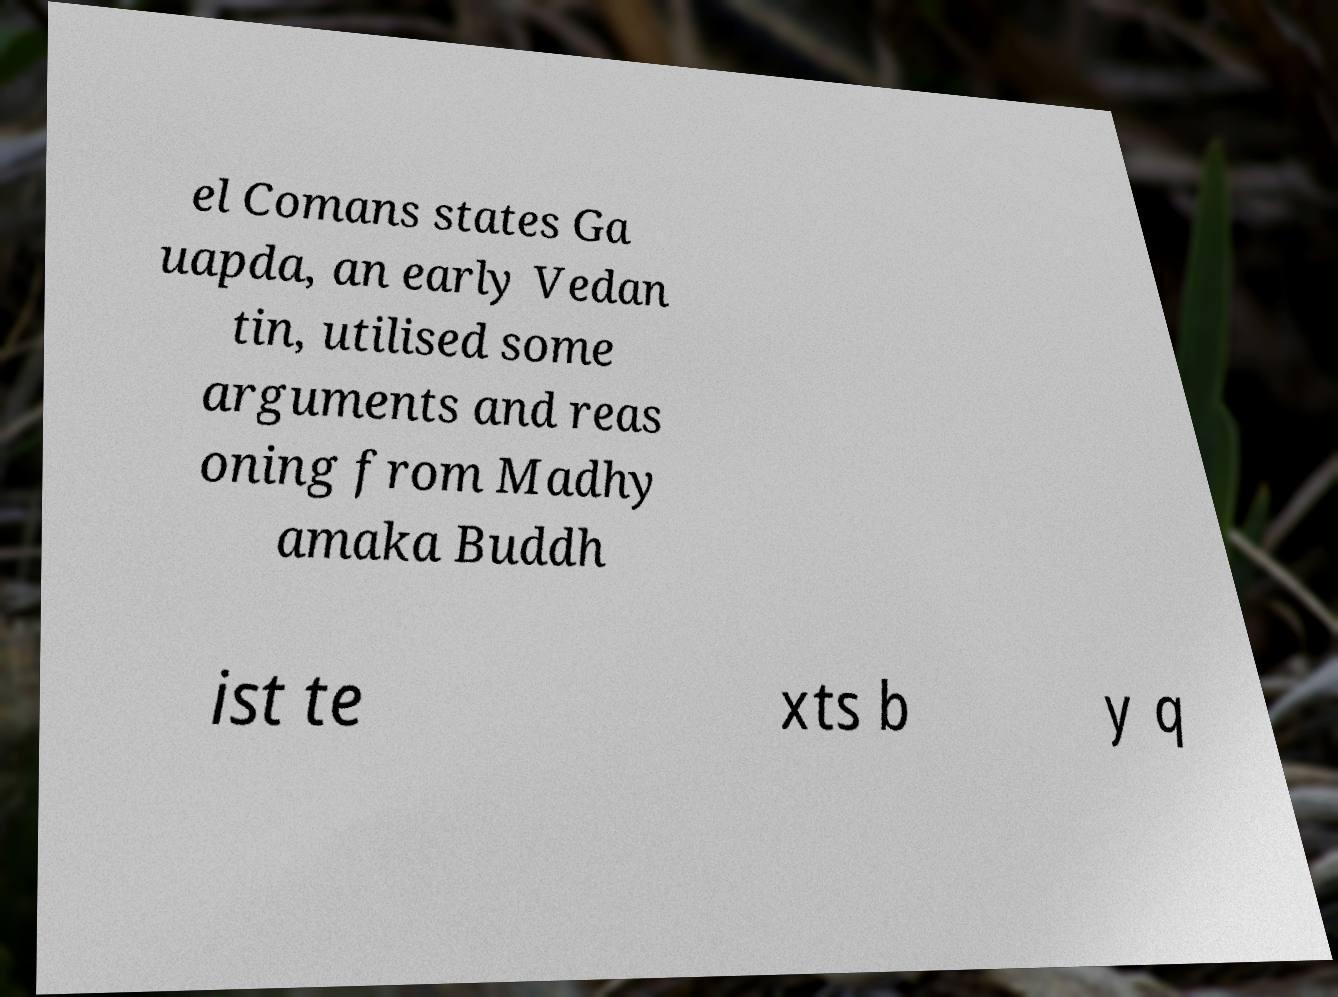What messages or text are displayed in this image? I need them in a readable, typed format. el Comans states Ga uapda, an early Vedan tin, utilised some arguments and reas oning from Madhy amaka Buddh ist te xts b y q 